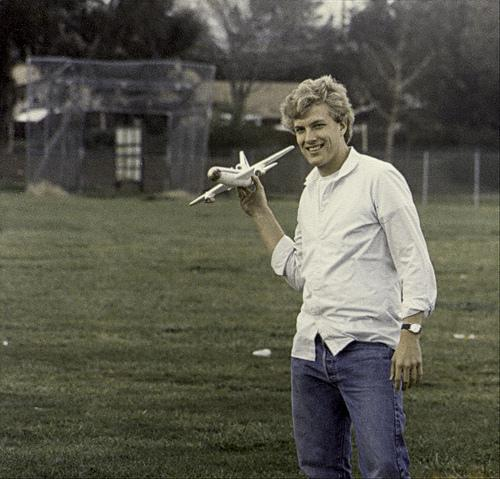Question: what type of pants is the man wearing?
Choices:
A. Slacks.
B. Shorts.
C. Sweats.
D. Jeans.
Answer with the letter. Answer: D Question: where was the picture taken?
Choices:
A. In a grassy field.
B. In a desert.
C. In a kitchen.
D. In a grocery store.
Answer with the letter. Answer: A Question: what is the man holding?
Choices:
A. A toy plane.
B. His cell phone.
C. The girls' hand.
D. Nothing.
Answer with the letter. Answer: A Question: what expression is on the man's face?
Choices:
A. Concern.
B. He looks happy.
C. Amusement.
D. A smile.
Answer with the letter. Answer: D 